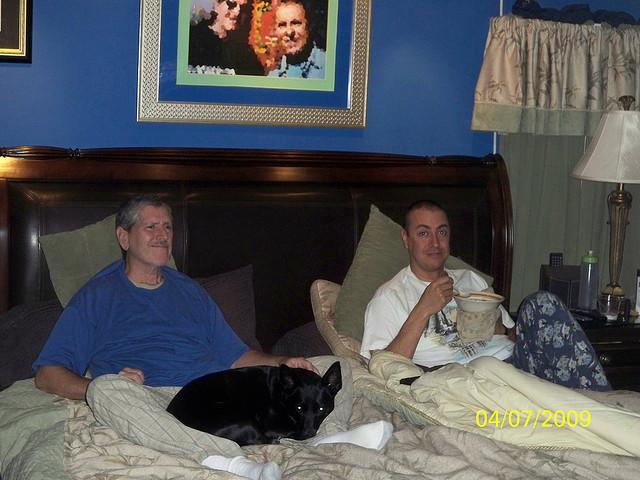Is the dog on the bed?
Be succinct. Yes. Where is the dog?
Short answer required. Bed. What is in the frame over the bed?
Give a very brief answer. Picture. 